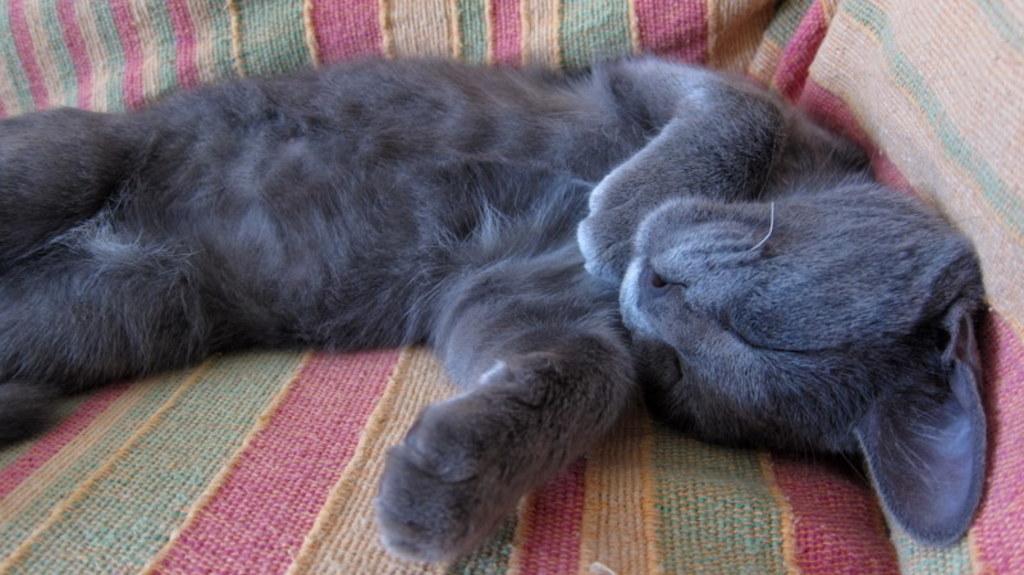Could you give a brief overview of what you see in this image? There is a gray color cat lying on the sofa. 